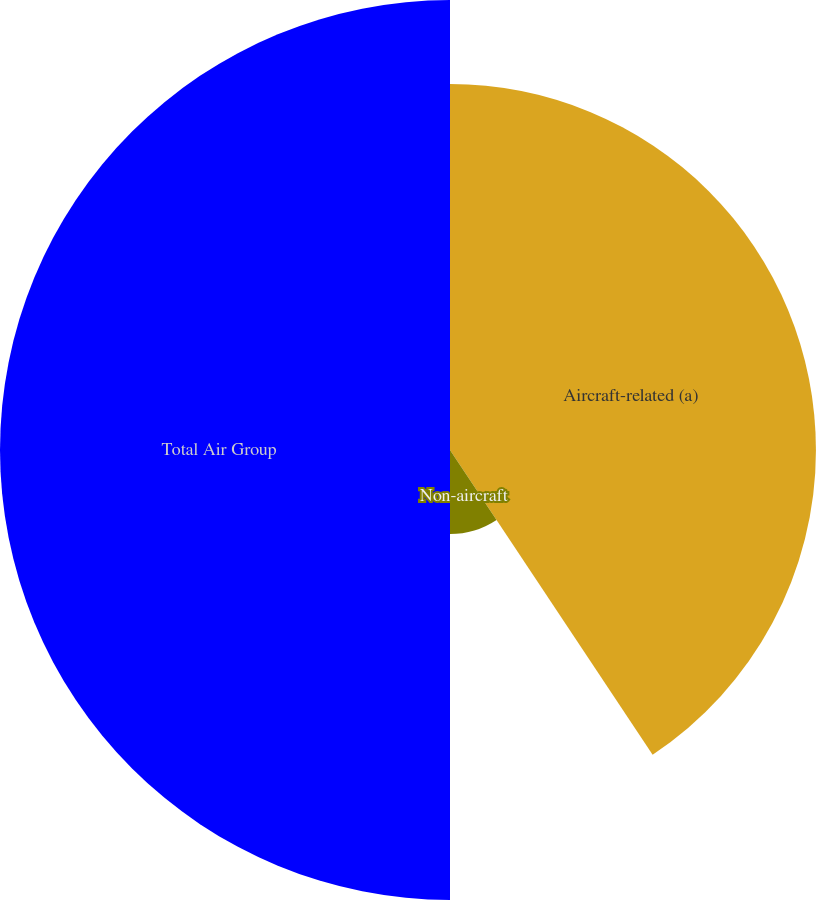Convert chart. <chart><loc_0><loc_0><loc_500><loc_500><pie_chart><fcel>Aircraft-related (a)<fcel>Non-aircraft<fcel>Total Air Group<nl><fcel>40.66%<fcel>9.34%<fcel>50.0%<nl></chart> 